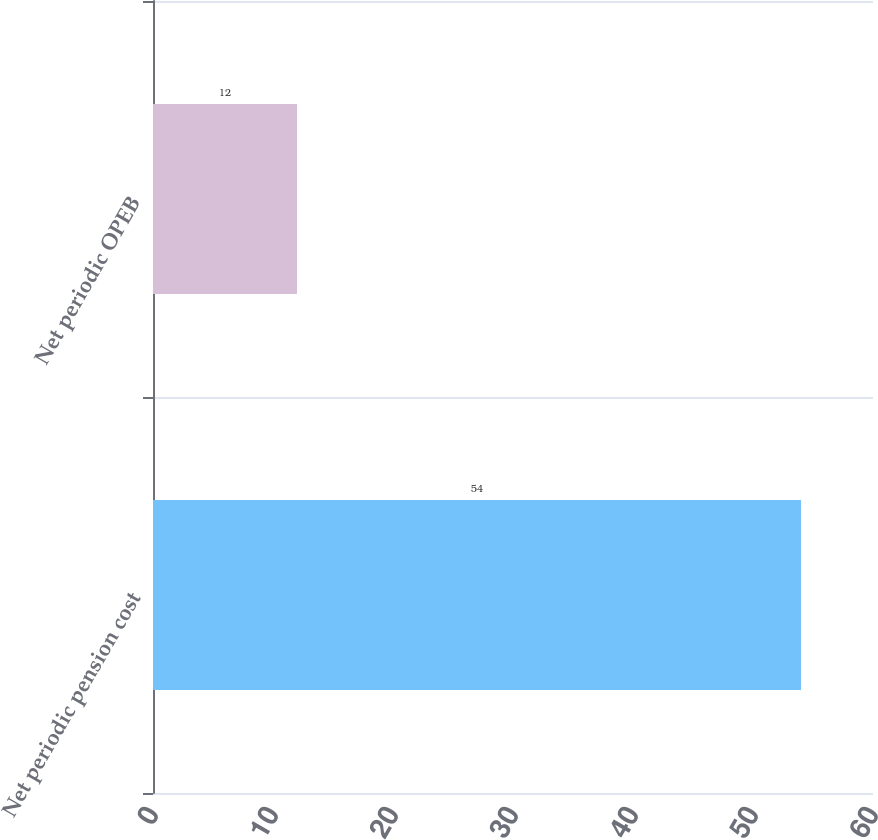Convert chart to OTSL. <chart><loc_0><loc_0><loc_500><loc_500><bar_chart><fcel>Net periodic pension cost<fcel>Net periodic OPEB<nl><fcel>54<fcel>12<nl></chart> 